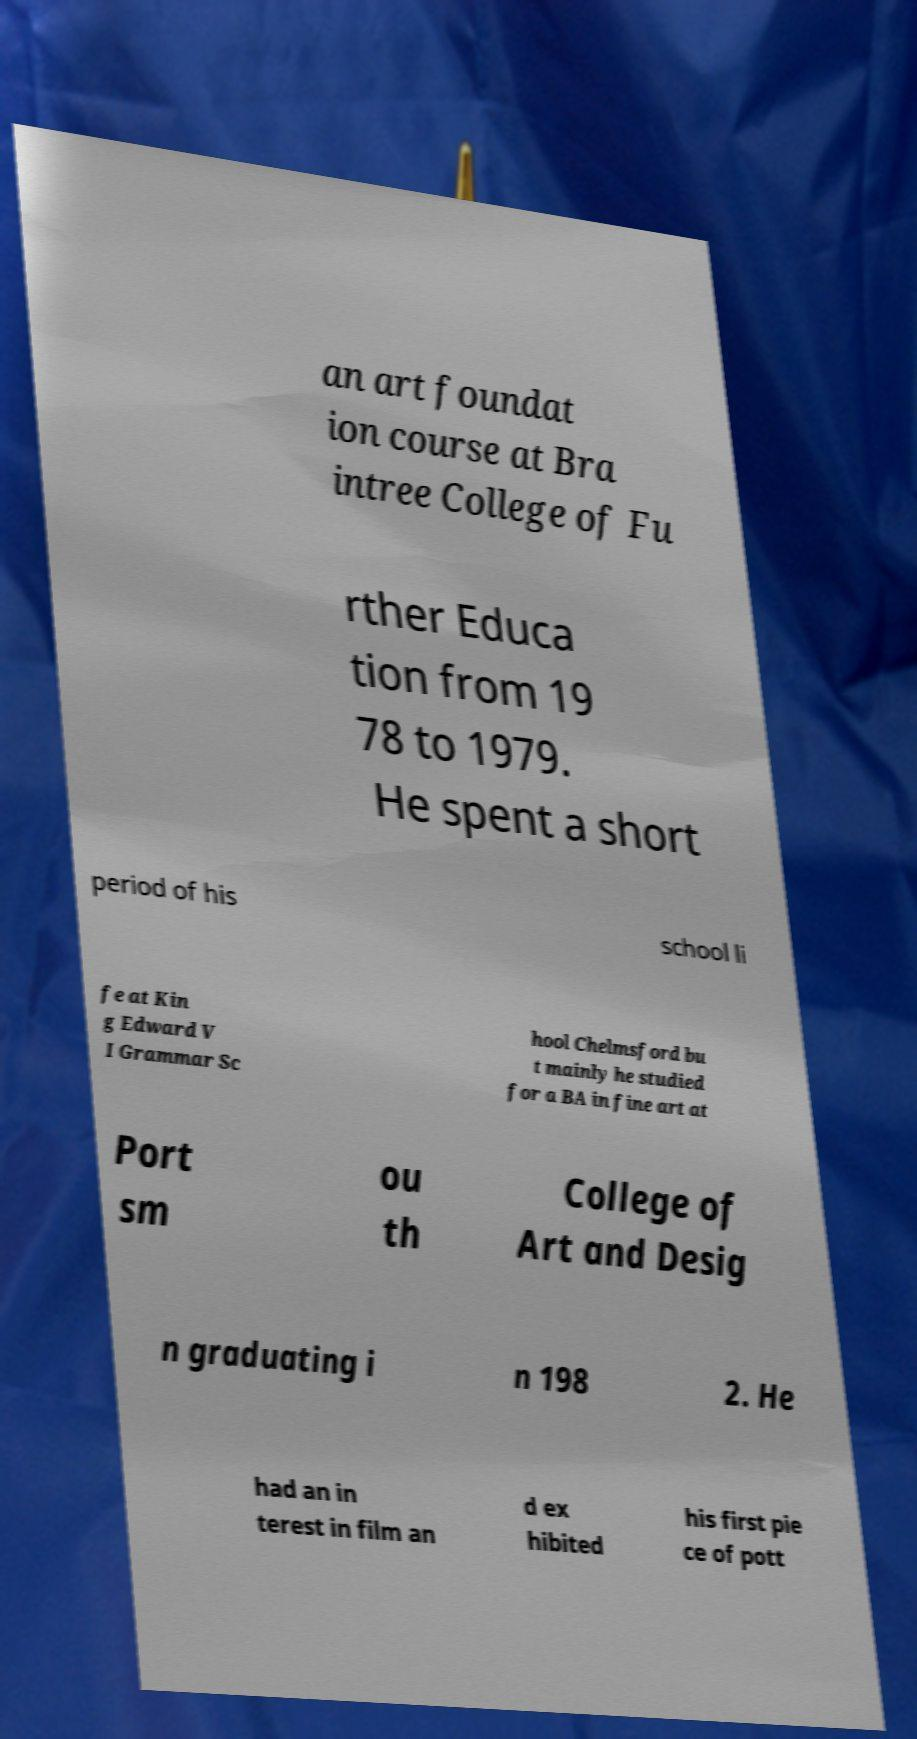There's text embedded in this image that I need extracted. Can you transcribe it verbatim? an art foundat ion course at Bra intree College of Fu rther Educa tion from 19 78 to 1979. He spent a short period of his school li fe at Kin g Edward V I Grammar Sc hool Chelmsford bu t mainly he studied for a BA in fine art at Port sm ou th College of Art and Desig n graduating i n 198 2. He had an in terest in film an d ex hibited his first pie ce of pott 